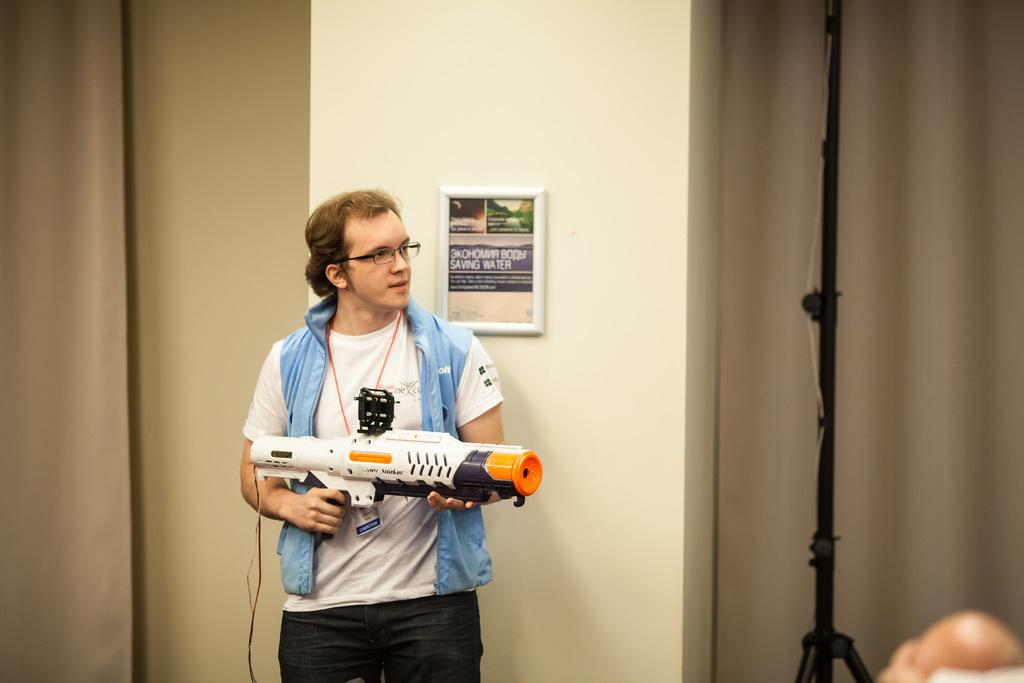What is the person in the image holding? The person is holding a Nerf super soaker hydro cannon. What can be seen on the wall in the background of the image? There is there a frame attached to the wall? What other objects can be seen in the background of the image? There is a tripod stand and curtains in the background of the image. What type of plate is being used to level the pipe in the image? There is no plate or pipe present in the image; it features a person holding a Nerf super soaker hydro cannon and various objects in the background. 